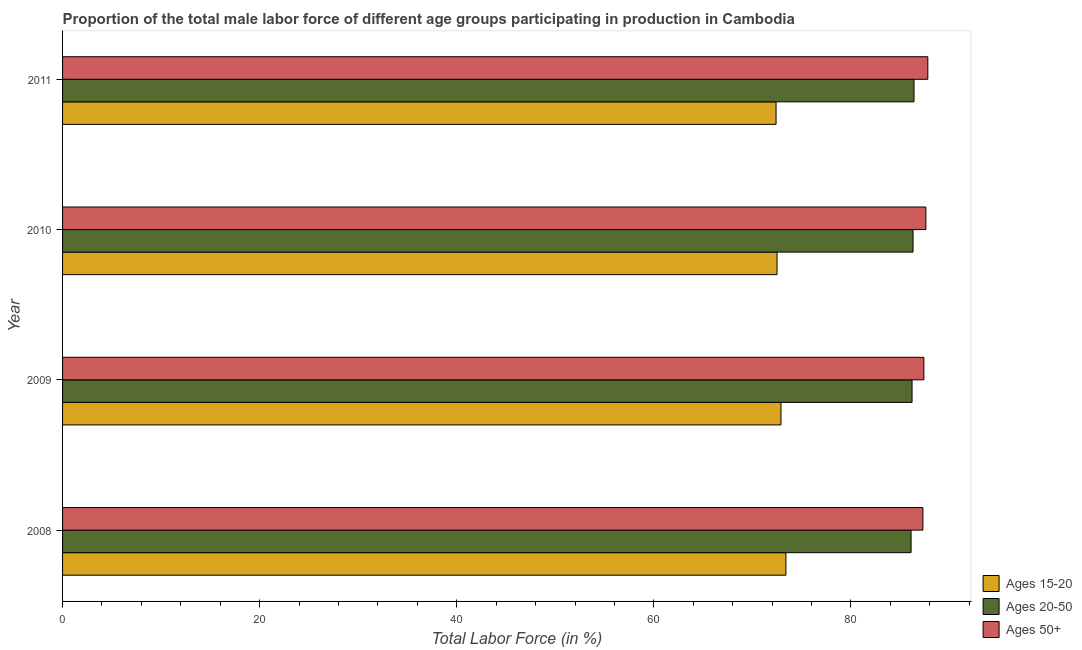How many different coloured bars are there?
Your answer should be very brief. 3. Are the number of bars per tick equal to the number of legend labels?
Offer a terse response. Yes. How many bars are there on the 4th tick from the top?
Provide a short and direct response. 3. How many bars are there on the 1st tick from the bottom?
Offer a very short reply. 3. In how many cases, is the number of bars for a given year not equal to the number of legend labels?
Offer a very short reply. 0. What is the percentage of male labor force above age 50 in 2008?
Provide a short and direct response. 87.3. Across all years, what is the maximum percentage of male labor force within the age group 20-50?
Your response must be concise. 86.4. Across all years, what is the minimum percentage of male labor force within the age group 15-20?
Give a very brief answer. 72.4. In which year was the percentage of male labor force within the age group 20-50 maximum?
Give a very brief answer. 2011. What is the total percentage of male labor force above age 50 in the graph?
Make the answer very short. 350.1. What is the average percentage of male labor force above age 50 per year?
Offer a terse response. 87.53. In how many years, is the percentage of male labor force within the age group 20-50 greater than 36 %?
Your answer should be very brief. 4. What is the ratio of the percentage of male labor force within the age group 20-50 in 2009 to that in 2010?
Give a very brief answer. 1. Is the percentage of male labor force within the age group 15-20 in 2010 less than that in 2011?
Provide a short and direct response. No. What is the difference between the highest and the second highest percentage of male labor force within the age group 20-50?
Your answer should be compact. 0.1. What does the 1st bar from the top in 2008 represents?
Make the answer very short. Ages 50+. What does the 2nd bar from the bottom in 2011 represents?
Give a very brief answer. Ages 20-50. What is the difference between two consecutive major ticks on the X-axis?
Provide a succinct answer. 20. How many legend labels are there?
Make the answer very short. 3. How are the legend labels stacked?
Keep it short and to the point. Vertical. What is the title of the graph?
Provide a short and direct response. Proportion of the total male labor force of different age groups participating in production in Cambodia. What is the label or title of the Y-axis?
Offer a very short reply. Year. What is the Total Labor Force (in %) in Ages 15-20 in 2008?
Make the answer very short. 73.4. What is the Total Labor Force (in %) in Ages 20-50 in 2008?
Your response must be concise. 86.1. What is the Total Labor Force (in %) in Ages 50+ in 2008?
Ensure brevity in your answer.  87.3. What is the Total Labor Force (in %) of Ages 15-20 in 2009?
Your response must be concise. 72.9. What is the Total Labor Force (in %) of Ages 20-50 in 2009?
Offer a very short reply. 86.2. What is the Total Labor Force (in %) of Ages 50+ in 2009?
Provide a short and direct response. 87.4. What is the Total Labor Force (in %) of Ages 15-20 in 2010?
Offer a terse response. 72.5. What is the Total Labor Force (in %) of Ages 20-50 in 2010?
Provide a short and direct response. 86.3. What is the Total Labor Force (in %) of Ages 50+ in 2010?
Your answer should be very brief. 87.6. What is the Total Labor Force (in %) of Ages 15-20 in 2011?
Your answer should be compact. 72.4. What is the Total Labor Force (in %) of Ages 20-50 in 2011?
Ensure brevity in your answer.  86.4. What is the Total Labor Force (in %) of Ages 50+ in 2011?
Offer a very short reply. 87.8. Across all years, what is the maximum Total Labor Force (in %) of Ages 15-20?
Provide a succinct answer. 73.4. Across all years, what is the maximum Total Labor Force (in %) in Ages 20-50?
Ensure brevity in your answer.  86.4. Across all years, what is the maximum Total Labor Force (in %) in Ages 50+?
Your answer should be very brief. 87.8. Across all years, what is the minimum Total Labor Force (in %) of Ages 15-20?
Your answer should be very brief. 72.4. Across all years, what is the minimum Total Labor Force (in %) in Ages 20-50?
Provide a succinct answer. 86.1. Across all years, what is the minimum Total Labor Force (in %) of Ages 50+?
Ensure brevity in your answer.  87.3. What is the total Total Labor Force (in %) in Ages 15-20 in the graph?
Give a very brief answer. 291.2. What is the total Total Labor Force (in %) of Ages 20-50 in the graph?
Provide a succinct answer. 345. What is the total Total Labor Force (in %) of Ages 50+ in the graph?
Offer a very short reply. 350.1. What is the difference between the Total Labor Force (in %) of Ages 20-50 in 2008 and that in 2009?
Your answer should be very brief. -0.1. What is the difference between the Total Labor Force (in %) in Ages 15-20 in 2008 and that in 2010?
Keep it short and to the point. 0.9. What is the difference between the Total Labor Force (in %) in Ages 50+ in 2008 and that in 2010?
Your answer should be very brief. -0.3. What is the difference between the Total Labor Force (in %) in Ages 50+ in 2008 and that in 2011?
Your answer should be very brief. -0.5. What is the difference between the Total Labor Force (in %) of Ages 15-20 in 2009 and that in 2010?
Make the answer very short. 0.4. What is the difference between the Total Labor Force (in %) in Ages 50+ in 2009 and that in 2010?
Your response must be concise. -0.2. What is the difference between the Total Labor Force (in %) of Ages 20-50 in 2009 and that in 2011?
Keep it short and to the point. -0.2. What is the difference between the Total Labor Force (in %) of Ages 50+ in 2009 and that in 2011?
Provide a short and direct response. -0.4. What is the difference between the Total Labor Force (in %) in Ages 15-20 in 2010 and that in 2011?
Keep it short and to the point. 0.1. What is the difference between the Total Labor Force (in %) in Ages 15-20 in 2008 and the Total Labor Force (in %) in Ages 20-50 in 2009?
Give a very brief answer. -12.8. What is the difference between the Total Labor Force (in %) of Ages 15-20 in 2008 and the Total Labor Force (in %) of Ages 50+ in 2009?
Your answer should be compact. -14. What is the difference between the Total Labor Force (in %) in Ages 15-20 in 2008 and the Total Labor Force (in %) in Ages 50+ in 2010?
Offer a very short reply. -14.2. What is the difference between the Total Labor Force (in %) in Ages 15-20 in 2008 and the Total Labor Force (in %) in Ages 50+ in 2011?
Keep it short and to the point. -14.4. What is the difference between the Total Labor Force (in %) in Ages 15-20 in 2009 and the Total Labor Force (in %) in Ages 50+ in 2010?
Ensure brevity in your answer.  -14.7. What is the difference between the Total Labor Force (in %) of Ages 20-50 in 2009 and the Total Labor Force (in %) of Ages 50+ in 2010?
Your answer should be very brief. -1.4. What is the difference between the Total Labor Force (in %) of Ages 15-20 in 2009 and the Total Labor Force (in %) of Ages 50+ in 2011?
Your answer should be compact. -14.9. What is the difference between the Total Labor Force (in %) in Ages 15-20 in 2010 and the Total Labor Force (in %) in Ages 50+ in 2011?
Give a very brief answer. -15.3. What is the difference between the Total Labor Force (in %) of Ages 20-50 in 2010 and the Total Labor Force (in %) of Ages 50+ in 2011?
Provide a succinct answer. -1.5. What is the average Total Labor Force (in %) in Ages 15-20 per year?
Offer a very short reply. 72.8. What is the average Total Labor Force (in %) in Ages 20-50 per year?
Your answer should be very brief. 86.25. What is the average Total Labor Force (in %) in Ages 50+ per year?
Provide a succinct answer. 87.53. In the year 2008, what is the difference between the Total Labor Force (in %) in Ages 15-20 and Total Labor Force (in %) in Ages 20-50?
Your response must be concise. -12.7. In the year 2008, what is the difference between the Total Labor Force (in %) in Ages 20-50 and Total Labor Force (in %) in Ages 50+?
Your answer should be compact. -1.2. In the year 2009, what is the difference between the Total Labor Force (in %) in Ages 15-20 and Total Labor Force (in %) in Ages 50+?
Provide a short and direct response. -14.5. In the year 2010, what is the difference between the Total Labor Force (in %) of Ages 15-20 and Total Labor Force (in %) of Ages 20-50?
Your answer should be compact. -13.8. In the year 2010, what is the difference between the Total Labor Force (in %) in Ages 15-20 and Total Labor Force (in %) in Ages 50+?
Keep it short and to the point. -15.1. In the year 2010, what is the difference between the Total Labor Force (in %) of Ages 20-50 and Total Labor Force (in %) of Ages 50+?
Provide a succinct answer. -1.3. In the year 2011, what is the difference between the Total Labor Force (in %) in Ages 15-20 and Total Labor Force (in %) in Ages 20-50?
Offer a very short reply. -14. In the year 2011, what is the difference between the Total Labor Force (in %) of Ages 15-20 and Total Labor Force (in %) of Ages 50+?
Make the answer very short. -15.4. In the year 2011, what is the difference between the Total Labor Force (in %) in Ages 20-50 and Total Labor Force (in %) in Ages 50+?
Provide a succinct answer. -1.4. What is the ratio of the Total Labor Force (in %) of Ages 15-20 in 2008 to that in 2009?
Your response must be concise. 1.01. What is the ratio of the Total Labor Force (in %) in Ages 50+ in 2008 to that in 2009?
Make the answer very short. 1. What is the ratio of the Total Labor Force (in %) in Ages 15-20 in 2008 to that in 2010?
Offer a very short reply. 1.01. What is the ratio of the Total Labor Force (in %) in Ages 20-50 in 2008 to that in 2010?
Your response must be concise. 1. What is the ratio of the Total Labor Force (in %) of Ages 15-20 in 2008 to that in 2011?
Keep it short and to the point. 1.01. What is the ratio of the Total Labor Force (in %) of Ages 20-50 in 2008 to that in 2011?
Offer a very short reply. 1. What is the ratio of the Total Labor Force (in %) in Ages 15-20 in 2009 to that in 2011?
Your answer should be compact. 1.01. What is the ratio of the Total Labor Force (in %) in Ages 50+ in 2009 to that in 2011?
Your answer should be compact. 1. What is the ratio of the Total Labor Force (in %) in Ages 15-20 in 2010 to that in 2011?
Keep it short and to the point. 1. What is the difference between the highest and the second highest Total Labor Force (in %) in Ages 15-20?
Make the answer very short. 0.5. What is the difference between the highest and the second highest Total Labor Force (in %) of Ages 20-50?
Keep it short and to the point. 0.1. What is the difference between the highest and the lowest Total Labor Force (in %) in Ages 15-20?
Provide a short and direct response. 1. What is the difference between the highest and the lowest Total Labor Force (in %) of Ages 20-50?
Offer a terse response. 0.3. 